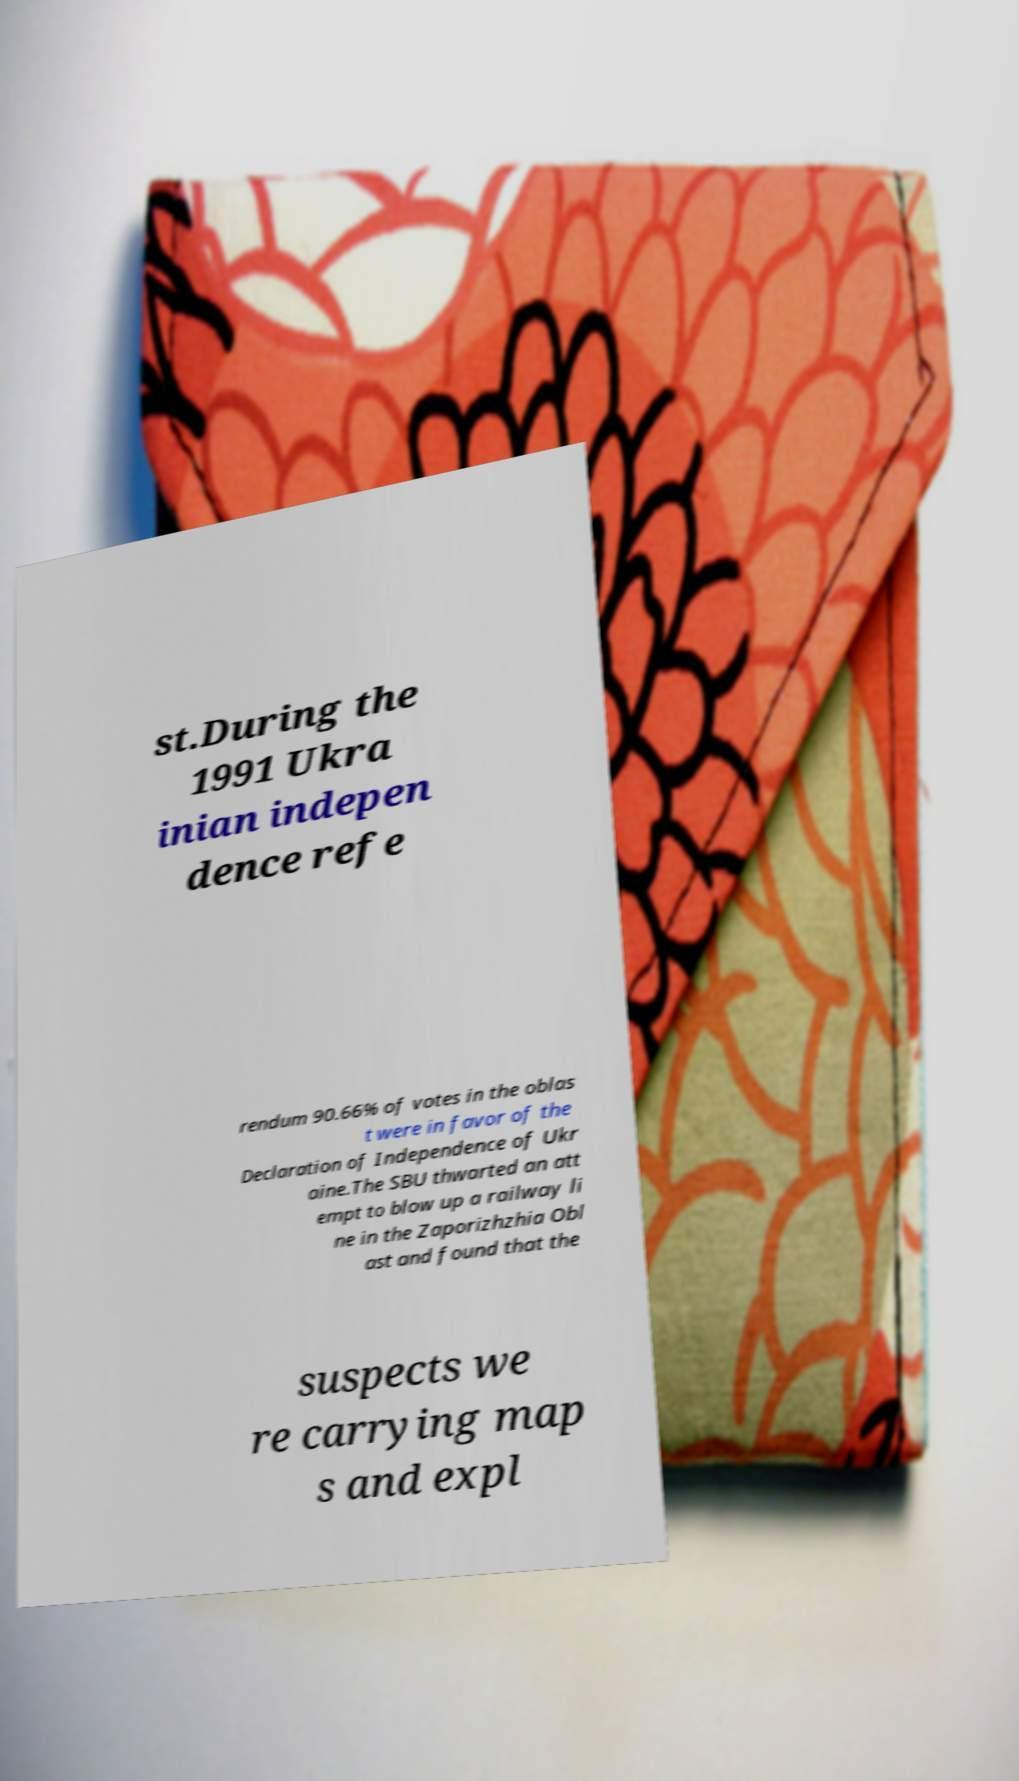Could you extract and type out the text from this image? st.During the 1991 Ukra inian indepen dence refe rendum 90.66% of votes in the oblas t were in favor of the Declaration of Independence of Ukr aine.The SBU thwarted an att empt to blow up a railway li ne in the Zaporizhzhia Obl ast and found that the suspects we re carrying map s and expl 